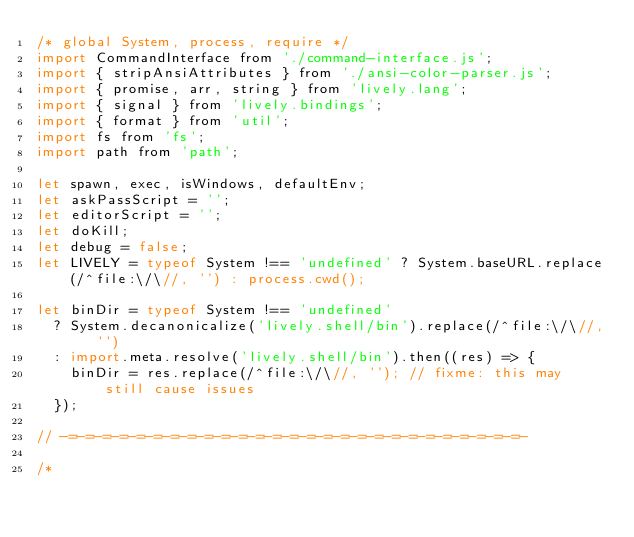<code> <loc_0><loc_0><loc_500><loc_500><_JavaScript_>/* global System, process, require */
import CommandInterface from './command-interface.js';
import { stripAnsiAttributes } from './ansi-color-parser.js';
import { promise, arr, string } from 'lively.lang';
import { signal } from 'lively.bindings';
import { format } from 'util';
import fs from 'fs';
import path from 'path';

let spawn, exec, isWindows, defaultEnv;
let askPassScript = '';
let editorScript = '';
let doKill;
let debug = false;
let LIVELY = typeof System !== 'undefined' ? System.baseURL.replace(/^file:\/\//, '') : process.cwd();

let binDir = typeof System !== 'undefined'
  ? System.decanonicalize('lively.shell/bin').replace(/^file:\/\//, '')
  : import.meta.resolve('lively.shell/bin').then((res) => {
    binDir = res.replace(/^file:\/\//, ''); // fixme: this may still cause issues
  });

// -=-=-=-=-=-=-=-=-=-=-=-=-=-=-=-=-=-=-=-=-=-=-=-=-=-=-=-

/*</code> 